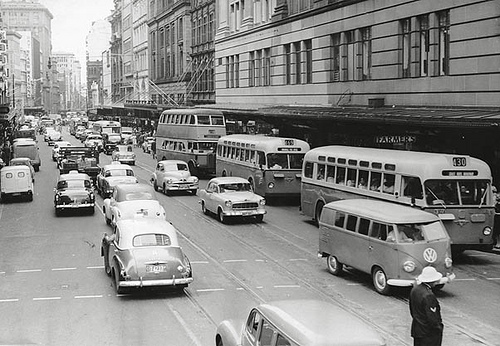Identify the text displayed in this image. FARMERS 130 